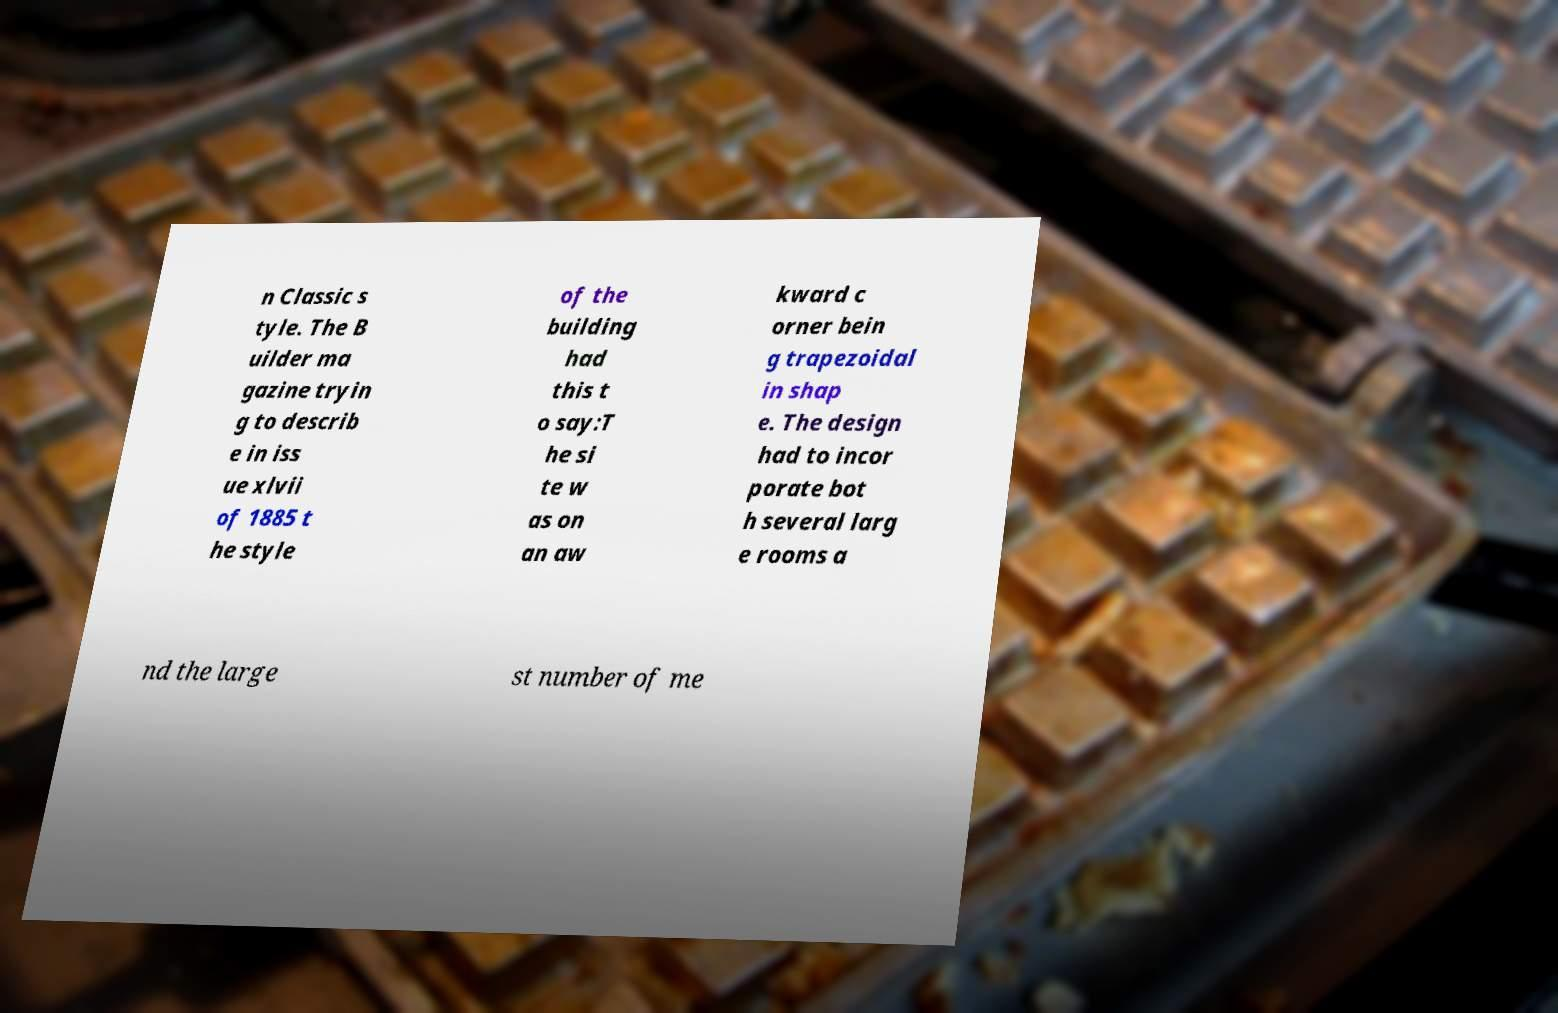Could you extract and type out the text from this image? n Classic s tyle. The B uilder ma gazine tryin g to describ e in iss ue xlvii of 1885 t he style of the building had this t o say:T he si te w as on an aw kward c orner bein g trapezoidal in shap e. The design had to incor porate bot h several larg e rooms a nd the large st number of me 